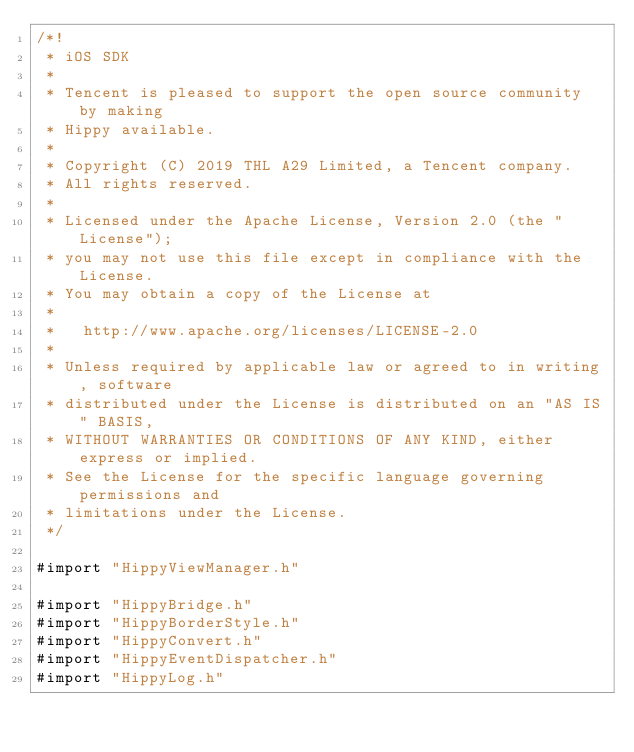Convert code to text. <code><loc_0><loc_0><loc_500><loc_500><_ObjectiveC_>/*!
 * iOS SDK
 *
 * Tencent is pleased to support the open source community by making
 * Hippy available.
 *
 * Copyright (C) 2019 THL A29 Limited, a Tencent company.
 * All rights reserved.
 *
 * Licensed under the Apache License, Version 2.0 (the "License");
 * you may not use this file except in compliance with the License.
 * You may obtain a copy of the License at
 *
 *   http://www.apache.org/licenses/LICENSE-2.0
 *
 * Unless required by applicable law or agreed to in writing, software
 * distributed under the License is distributed on an "AS IS" BASIS,
 * WITHOUT WARRANTIES OR CONDITIONS OF ANY KIND, either express or implied.
 * See the License for the specific language governing permissions and
 * limitations under the License.
 */

#import "HippyViewManager.h"

#import "HippyBridge.h"
#import "HippyBorderStyle.h"
#import "HippyConvert.h"
#import "HippyEventDispatcher.h"
#import "HippyLog.h"</code> 